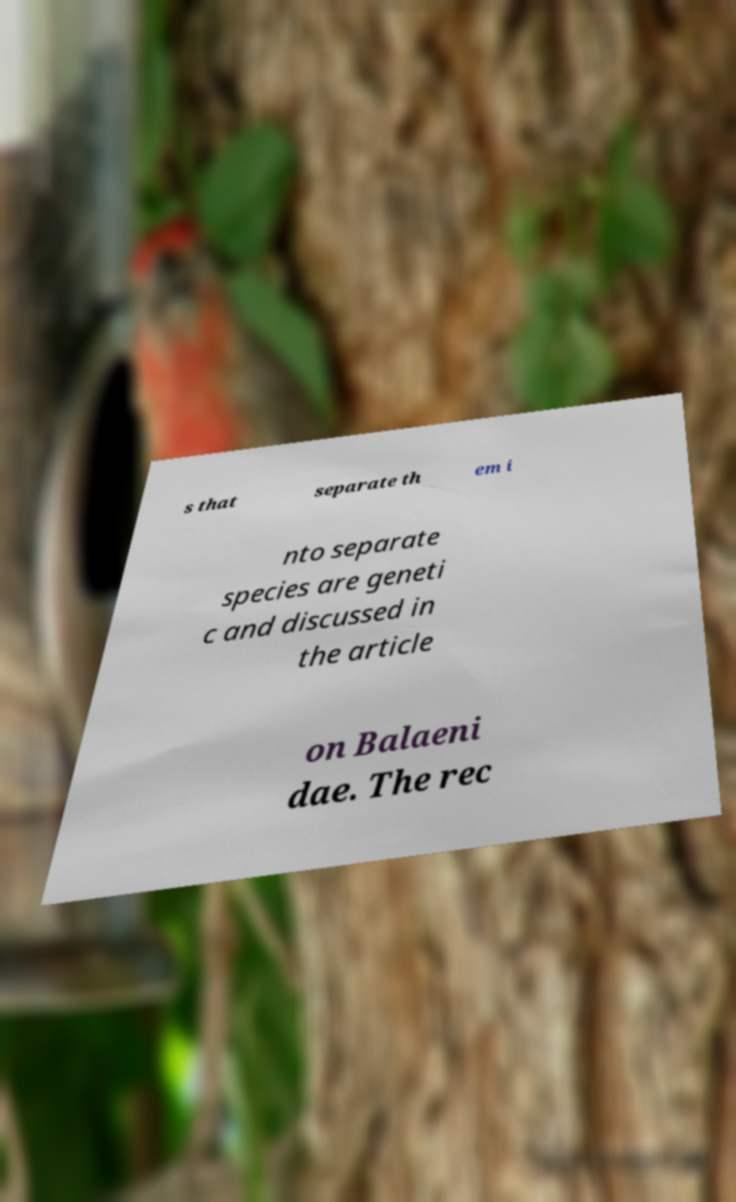What messages or text are displayed in this image? I need them in a readable, typed format. s that separate th em i nto separate species are geneti c and discussed in the article on Balaeni dae. The rec 